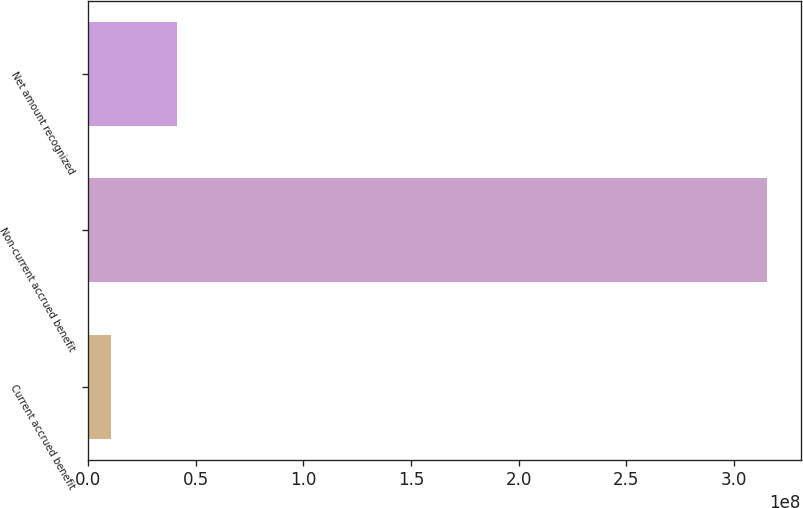Convert chart. <chart><loc_0><loc_0><loc_500><loc_500><bar_chart><fcel>Current accrued benefit<fcel>Non-current accrued benefit<fcel>Net amount recognized<nl><fcel>1.0784e+07<fcel>3.15251e+08<fcel>4.12307e+07<nl></chart> 